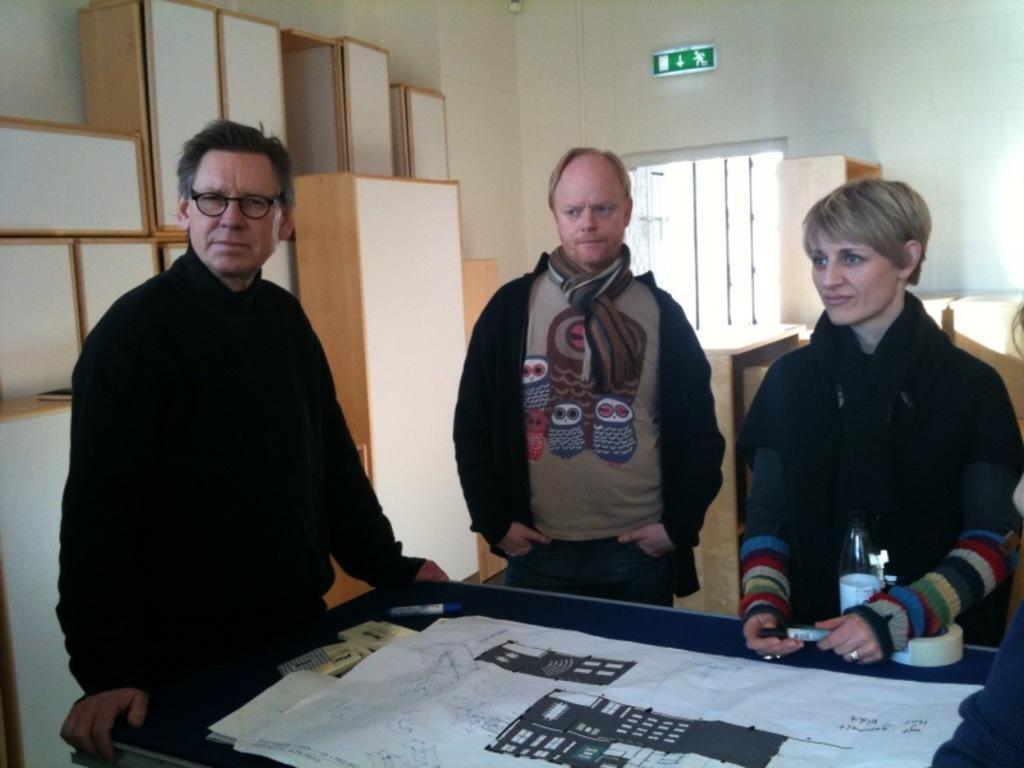In one or two sentences, can you explain what this image depicts? This image is taken indoors. In the background there is a wall with a window and there are many cupboards and there is a signboard. In the middle of the image a woman and two men are standing and there is a table with a few things on it. 